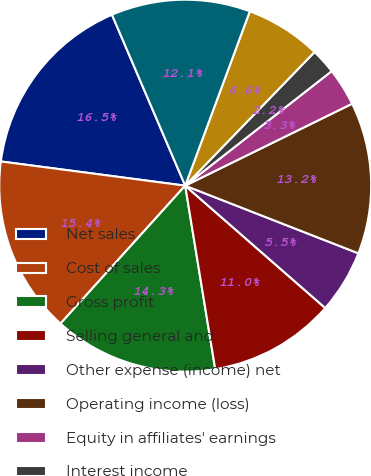Convert chart. <chart><loc_0><loc_0><loc_500><loc_500><pie_chart><fcel>Net sales<fcel>Cost of sales<fcel>Gross profit<fcel>Selling general and<fcel>Other expense (income) net<fcel>Operating income (loss)<fcel>Equity in affiliates' earnings<fcel>Interest income<fcel>Interest expense and finance<fcel>Earnings (loss) before income<nl><fcel>16.48%<fcel>15.38%<fcel>14.28%<fcel>10.99%<fcel>5.5%<fcel>13.19%<fcel>3.3%<fcel>2.2%<fcel>6.59%<fcel>12.09%<nl></chart> 